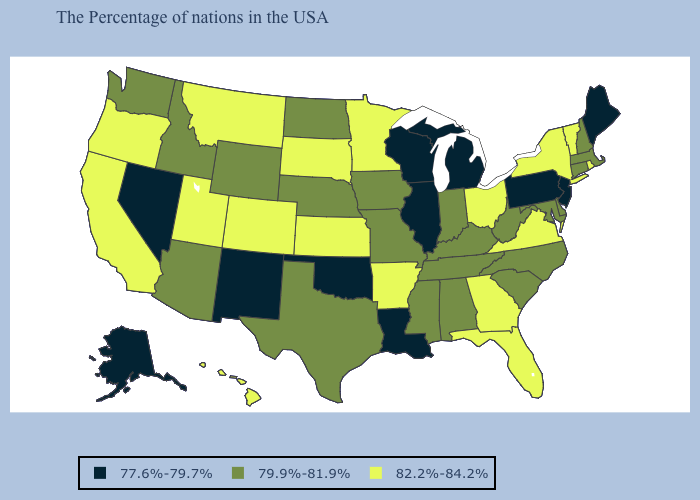What is the value of Montana?
Concise answer only. 82.2%-84.2%. Does the map have missing data?
Keep it brief. No. Among the states that border West Virginia , does Pennsylvania have the lowest value?
Give a very brief answer. Yes. What is the highest value in states that border Oklahoma?
Short answer required. 82.2%-84.2%. Among the states that border Illinois , which have the lowest value?
Concise answer only. Wisconsin. What is the highest value in the West ?
Answer briefly. 82.2%-84.2%. What is the value of Tennessee?
Keep it brief. 79.9%-81.9%. What is the value of Iowa?
Quick response, please. 79.9%-81.9%. What is the lowest value in the USA?
Answer briefly. 77.6%-79.7%. Does the map have missing data?
Keep it brief. No. Which states have the highest value in the USA?
Answer briefly. Rhode Island, Vermont, New York, Virginia, Ohio, Florida, Georgia, Arkansas, Minnesota, Kansas, South Dakota, Colorado, Utah, Montana, California, Oregon, Hawaii. Name the states that have a value in the range 82.2%-84.2%?
Keep it brief. Rhode Island, Vermont, New York, Virginia, Ohio, Florida, Georgia, Arkansas, Minnesota, Kansas, South Dakota, Colorado, Utah, Montana, California, Oregon, Hawaii. Among the states that border South Carolina , does North Carolina have the lowest value?
Answer briefly. Yes. Among the states that border Minnesota , does North Dakota have the highest value?
Write a very short answer. No. Which states have the lowest value in the USA?
Short answer required. Maine, New Jersey, Pennsylvania, Michigan, Wisconsin, Illinois, Louisiana, Oklahoma, New Mexico, Nevada, Alaska. 